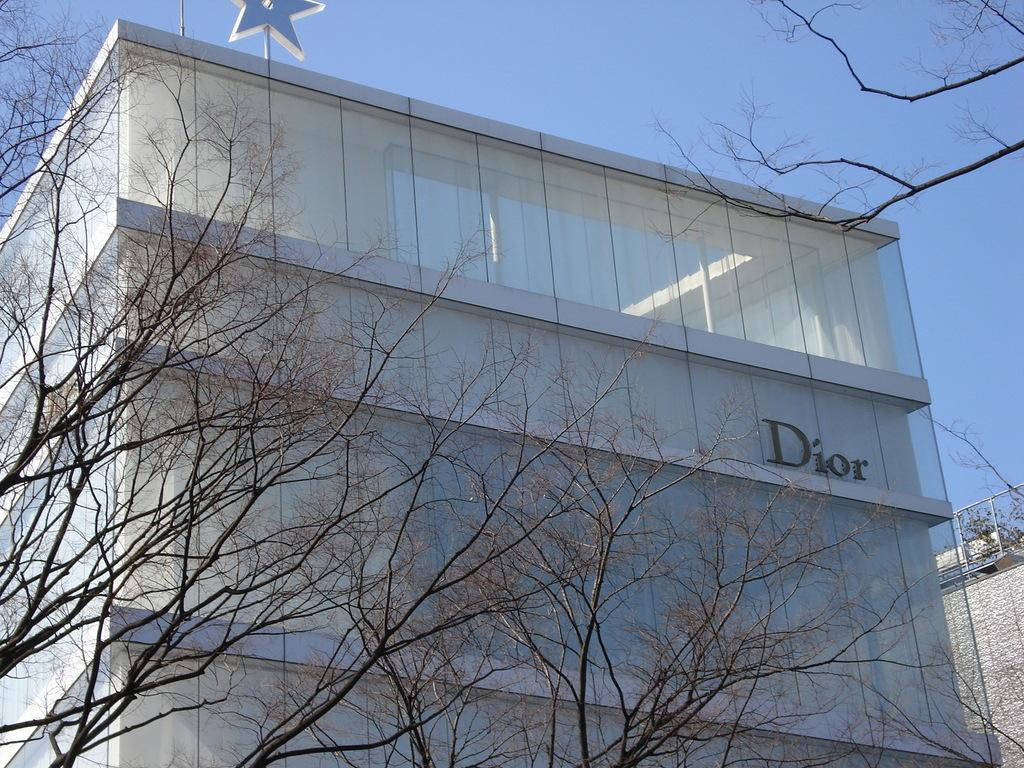What type of structure is in the image? There is a building in the image. What can be seen in the front of the building? There are many mirrors and glasses in the front of the building. What is located on the left side of the image? There are trees on the left side of the image. What is visible at the top of the image? The sky is visible at the top of the image. What type of division is taking place in the image? There is no division taking place in the image; it is a static representation of a building, mirrors, glasses, trees, and the sky. 